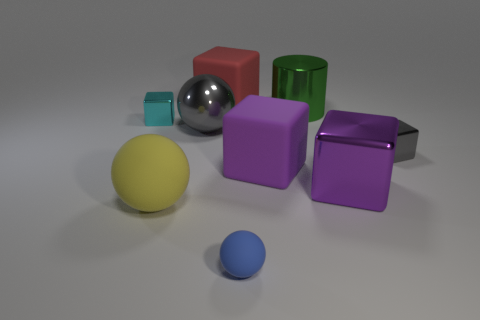Subtract all large spheres. How many spheres are left? 1 Add 1 large gray balls. How many objects exist? 10 Subtract all blue balls. How many balls are left? 2 Subtract 1 cylinders. How many cylinders are left? 0 Subtract 0 brown cylinders. How many objects are left? 9 Subtract all spheres. How many objects are left? 6 Subtract all brown cylinders. Subtract all purple spheres. How many cylinders are left? 1 Subtract all cyan balls. How many gray cubes are left? 1 Subtract all large spheres. Subtract all small gray shiny cubes. How many objects are left? 6 Add 1 cyan metallic cubes. How many cyan metallic cubes are left? 2 